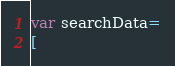<code> <loc_0><loc_0><loc_500><loc_500><_JavaScript_>var searchData=
[</code> 